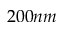<formula> <loc_0><loc_0><loc_500><loc_500>2 0 0 n m</formula> 